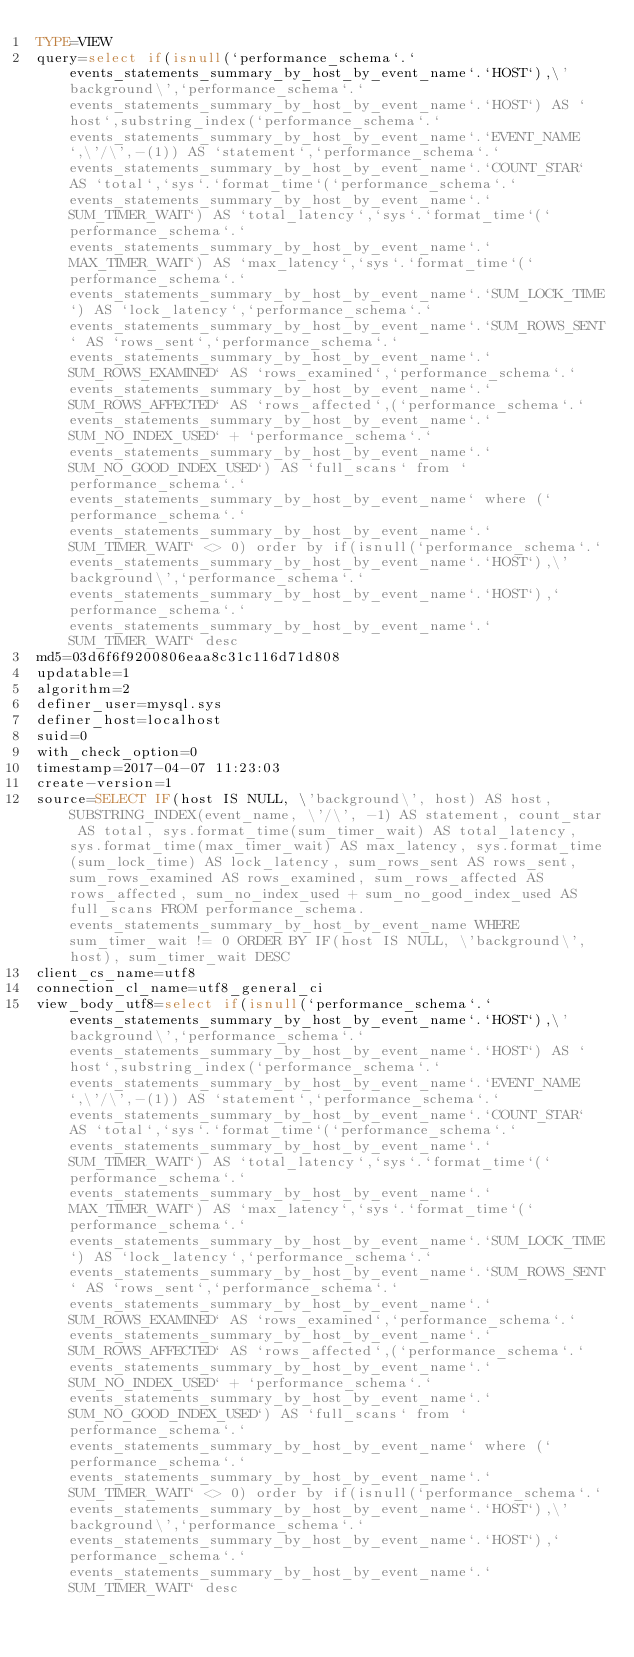Convert code to text. <code><loc_0><loc_0><loc_500><loc_500><_VisualBasic_>TYPE=VIEW
query=select if(isnull(`performance_schema`.`events_statements_summary_by_host_by_event_name`.`HOST`),\'background\',`performance_schema`.`events_statements_summary_by_host_by_event_name`.`HOST`) AS `host`,substring_index(`performance_schema`.`events_statements_summary_by_host_by_event_name`.`EVENT_NAME`,\'/\',-(1)) AS `statement`,`performance_schema`.`events_statements_summary_by_host_by_event_name`.`COUNT_STAR` AS `total`,`sys`.`format_time`(`performance_schema`.`events_statements_summary_by_host_by_event_name`.`SUM_TIMER_WAIT`) AS `total_latency`,`sys`.`format_time`(`performance_schema`.`events_statements_summary_by_host_by_event_name`.`MAX_TIMER_WAIT`) AS `max_latency`,`sys`.`format_time`(`performance_schema`.`events_statements_summary_by_host_by_event_name`.`SUM_LOCK_TIME`) AS `lock_latency`,`performance_schema`.`events_statements_summary_by_host_by_event_name`.`SUM_ROWS_SENT` AS `rows_sent`,`performance_schema`.`events_statements_summary_by_host_by_event_name`.`SUM_ROWS_EXAMINED` AS `rows_examined`,`performance_schema`.`events_statements_summary_by_host_by_event_name`.`SUM_ROWS_AFFECTED` AS `rows_affected`,(`performance_schema`.`events_statements_summary_by_host_by_event_name`.`SUM_NO_INDEX_USED` + `performance_schema`.`events_statements_summary_by_host_by_event_name`.`SUM_NO_GOOD_INDEX_USED`) AS `full_scans` from `performance_schema`.`events_statements_summary_by_host_by_event_name` where (`performance_schema`.`events_statements_summary_by_host_by_event_name`.`SUM_TIMER_WAIT` <> 0) order by if(isnull(`performance_schema`.`events_statements_summary_by_host_by_event_name`.`HOST`),\'background\',`performance_schema`.`events_statements_summary_by_host_by_event_name`.`HOST`),`performance_schema`.`events_statements_summary_by_host_by_event_name`.`SUM_TIMER_WAIT` desc
md5=03d6f6f9200806eaa8c31c116d71d808
updatable=1
algorithm=2
definer_user=mysql.sys
definer_host=localhost
suid=0
with_check_option=0
timestamp=2017-04-07 11:23:03
create-version=1
source=SELECT IF(host IS NULL, \'background\', host) AS host, SUBSTRING_INDEX(event_name, \'/\', -1) AS statement, count_star AS total, sys.format_time(sum_timer_wait) AS total_latency, sys.format_time(max_timer_wait) AS max_latency, sys.format_time(sum_lock_time) AS lock_latency, sum_rows_sent AS rows_sent, sum_rows_examined AS rows_examined, sum_rows_affected AS rows_affected, sum_no_index_used + sum_no_good_index_used AS full_scans FROM performance_schema.events_statements_summary_by_host_by_event_name WHERE sum_timer_wait != 0 ORDER BY IF(host IS NULL, \'background\', host), sum_timer_wait DESC
client_cs_name=utf8
connection_cl_name=utf8_general_ci
view_body_utf8=select if(isnull(`performance_schema`.`events_statements_summary_by_host_by_event_name`.`HOST`),\'background\',`performance_schema`.`events_statements_summary_by_host_by_event_name`.`HOST`) AS `host`,substring_index(`performance_schema`.`events_statements_summary_by_host_by_event_name`.`EVENT_NAME`,\'/\',-(1)) AS `statement`,`performance_schema`.`events_statements_summary_by_host_by_event_name`.`COUNT_STAR` AS `total`,`sys`.`format_time`(`performance_schema`.`events_statements_summary_by_host_by_event_name`.`SUM_TIMER_WAIT`) AS `total_latency`,`sys`.`format_time`(`performance_schema`.`events_statements_summary_by_host_by_event_name`.`MAX_TIMER_WAIT`) AS `max_latency`,`sys`.`format_time`(`performance_schema`.`events_statements_summary_by_host_by_event_name`.`SUM_LOCK_TIME`) AS `lock_latency`,`performance_schema`.`events_statements_summary_by_host_by_event_name`.`SUM_ROWS_SENT` AS `rows_sent`,`performance_schema`.`events_statements_summary_by_host_by_event_name`.`SUM_ROWS_EXAMINED` AS `rows_examined`,`performance_schema`.`events_statements_summary_by_host_by_event_name`.`SUM_ROWS_AFFECTED` AS `rows_affected`,(`performance_schema`.`events_statements_summary_by_host_by_event_name`.`SUM_NO_INDEX_USED` + `performance_schema`.`events_statements_summary_by_host_by_event_name`.`SUM_NO_GOOD_INDEX_USED`) AS `full_scans` from `performance_schema`.`events_statements_summary_by_host_by_event_name` where (`performance_schema`.`events_statements_summary_by_host_by_event_name`.`SUM_TIMER_WAIT` <> 0) order by if(isnull(`performance_schema`.`events_statements_summary_by_host_by_event_name`.`HOST`),\'background\',`performance_schema`.`events_statements_summary_by_host_by_event_name`.`HOST`),`performance_schema`.`events_statements_summary_by_host_by_event_name`.`SUM_TIMER_WAIT` desc
</code> 